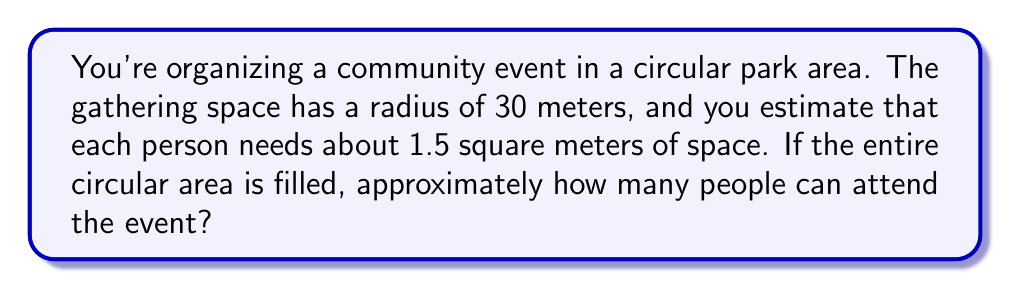Could you help me with this problem? To solve this problem, we need to follow these steps:

1. Calculate the area of the circular gathering space:
   The area of a circle is given by the formula $A = \pi r^2$, where $r$ is the radius.
   $$A = \pi \cdot 30^2 = 900\pi \approx 2827.43 \text{ square meters}$$

2. Determine the space needed per person:
   Each person needs 1.5 square meters of space.

3. Calculate the number of people that can fit in the area:
   Divide the total area by the space needed per person:
   $$\text{Number of people} = \frac{\text{Total area}}{\text{Space per person}} = \frac{2827.43}{1.5} \approx 1884.95$$

4. Round down to the nearest whole number:
   Since we can't have a fraction of a person, we round down to 1884 people.

[asy]
import geometry;

size(200);
fill(circle((0,0), 30), rgb(0.9,0.9,1));
draw(circle((0,0), 30));
label("30 m", (15,0), E);
dot((0,0));
draw((0,0)--(30,0));
[/asy]
Answer: Approximately 1884 people can attend the event in the circular gathering area. 